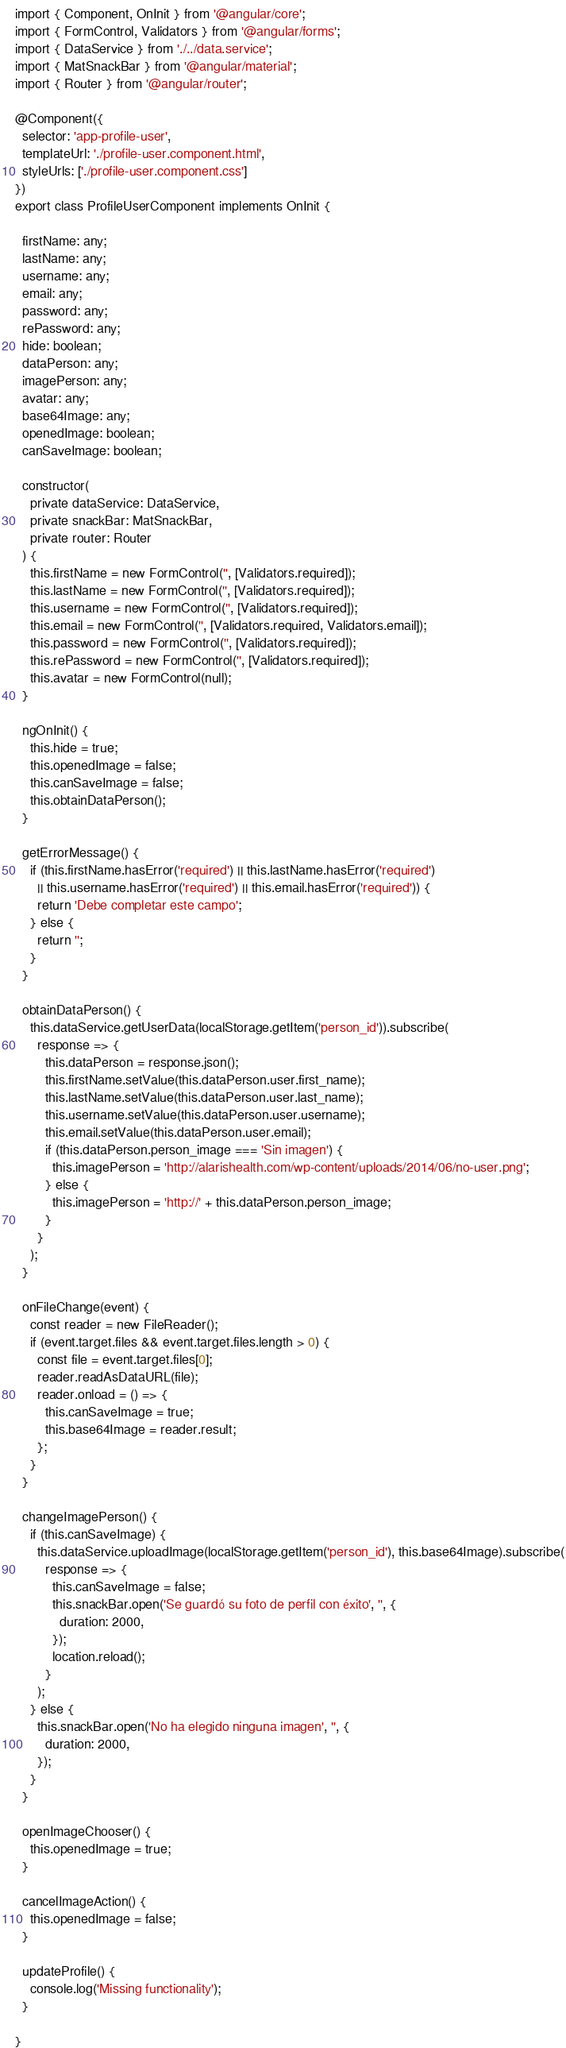Convert code to text. <code><loc_0><loc_0><loc_500><loc_500><_TypeScript_>import { Component, OnInit } from '@angular/core';
import { FormControl, Validators } from '@angular/forms';
import { DataService } from './../data.service';
import { MatSnackBar } from '@angular/material';
import { Router } from '@angular/router';

@Component({
  selector: 'app-profile-user',
  templateUrl: './profile-user.component.html',
  styleUrls: ['./profile-user.component.css']
})
export class ProfileUserComponent implements OnInit {

  firstName: any;
  lastName: any;
  username: any;
  email: any;
  password: any;
  rePassword: any;
  hide: boolean;
  dataPerson: any;
  imagePerson: any;
  avatar: any;
  base64Image: any;
  openedImage: boolean;
  canSaveImage: boolean;

  constructor(
    private dataService: DataService,
    private snackBar: MatSnackBar,
    private router: Router
  ) {
    this.firstName = new FormControl('', [Validators.required]);
    this.lastName = new FormControl('', [Validators.required]);
    this.username = new FormControl('', [Validators.required]);
    this.email = new FormControl('', [Validators.required, Validators.email]);
    this.password = new FormControl('', [Validators.required]);
    this.rePassword = new FormControl('', [Validators.required]);
    this.avatar = new FormControl(null);
  }

  ngOnInit() {
    this.hide = true;
    this.openedImage = false;
    this.canSaveImage = false;
    this.obtainDataPerson();
  }

  getErrorMessage() {
    if (this.firstName.hasError('required') || this.lastName.hasError('required')
      || this.username.hasError('required') || this.email.hasError('required')) {
      return 'Debe completar este campo';
    } else {
      return '';
    }
  }

  obtainDataPerson() {
    this.dataService.getUserData(localStorage.getItem('person_id')).subscribe(
      response => {
        this.dataPerson = response.json();
        this.firstName.setValue(this.dataPerson.user.first_name);
        this.lastName.setValue(this.dataPerson.user.last_name);
        this.username.setValue(this.dataPerson.user.username);
        this.email.setValue(this.dataPerson.user.email);
        if (this.dataPerson.person_image === 'Sin imagen') {
          this.imagePerson = 'http://alarishealth.com/wp-content/uploads/2014/06/no-user.png';
        } else {
          this.imagePerson = 'http://' + this.dataPerson.person_image;
        }
      }
    );
  }

  onFileChange(event) {
    const reader = new FileReader();
    if (event.target.files && event.target.files.length > 0) {
      const file = event.target.files[0];
      reader.readAsDataURL(file);
      reader.onload = () => {
        this.canSaveImage = true;
        this.base64Image = reader.result;
      };
    }
  }

  changeImagePerson() {
    if (this.canSaveImage) {
      this.dataService.uploadImage(localStorage.getItem('person_id'), this.base64Image).subscribe(
        response => {
          this.canSaveImage = false;
          this.snackBar.open('Se guardó su foto de perfil con éxito', '', {
            duration: 2000,
          });
          location.reload();
        }
      );
    } else {
      this.snackBar.open('No ha elegido ninguna imagen', '', {
        duration: 2000,
      });
    }
  }

  openImageChooser() {
    this.openedImage = true;
  }

  cancelImageAction() {
    this.openedImage = false;
  }

  updateProfile() {
    console.log('Missing functionality');
  }

}
</code> 